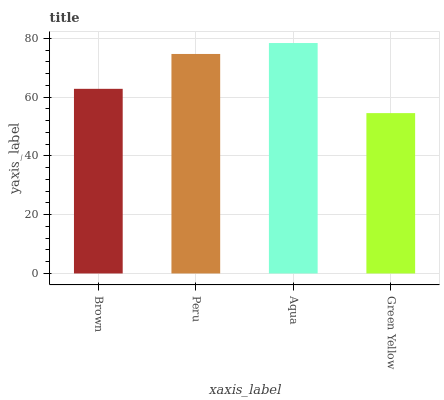Is Green Yellow the minimum?
Answer yes or no. Yes. Is Aqua the maximum?
Answer yes or no. Yes. Is Peru the minimum?
Answer yes or no. No. Is Peru the maximum?
Answer yes or no. No. Is Peru greater than Brown?
Answer yes or no. Yes. Is Brown less than Peru?
Answer yes or no. Yes. Is Brown greater than Peru?
Answer yes or no. No. Is Peru less than Brown?
Answer yes or no. No. Is Peru the high median?
Answer yes or no. Yes. Is Brown the low median?
Answer yes or no. Yes. Is Green Yellow the high median?
Answer yes or no. No. Is Aqua the low median?
Answer yes or no. No. 